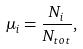<formula> <loc_0><loc_0><loc_500><loc_500>\mu _ { i } = \frac { N _ { i } } { N _ { t o t } } ,</formula> 